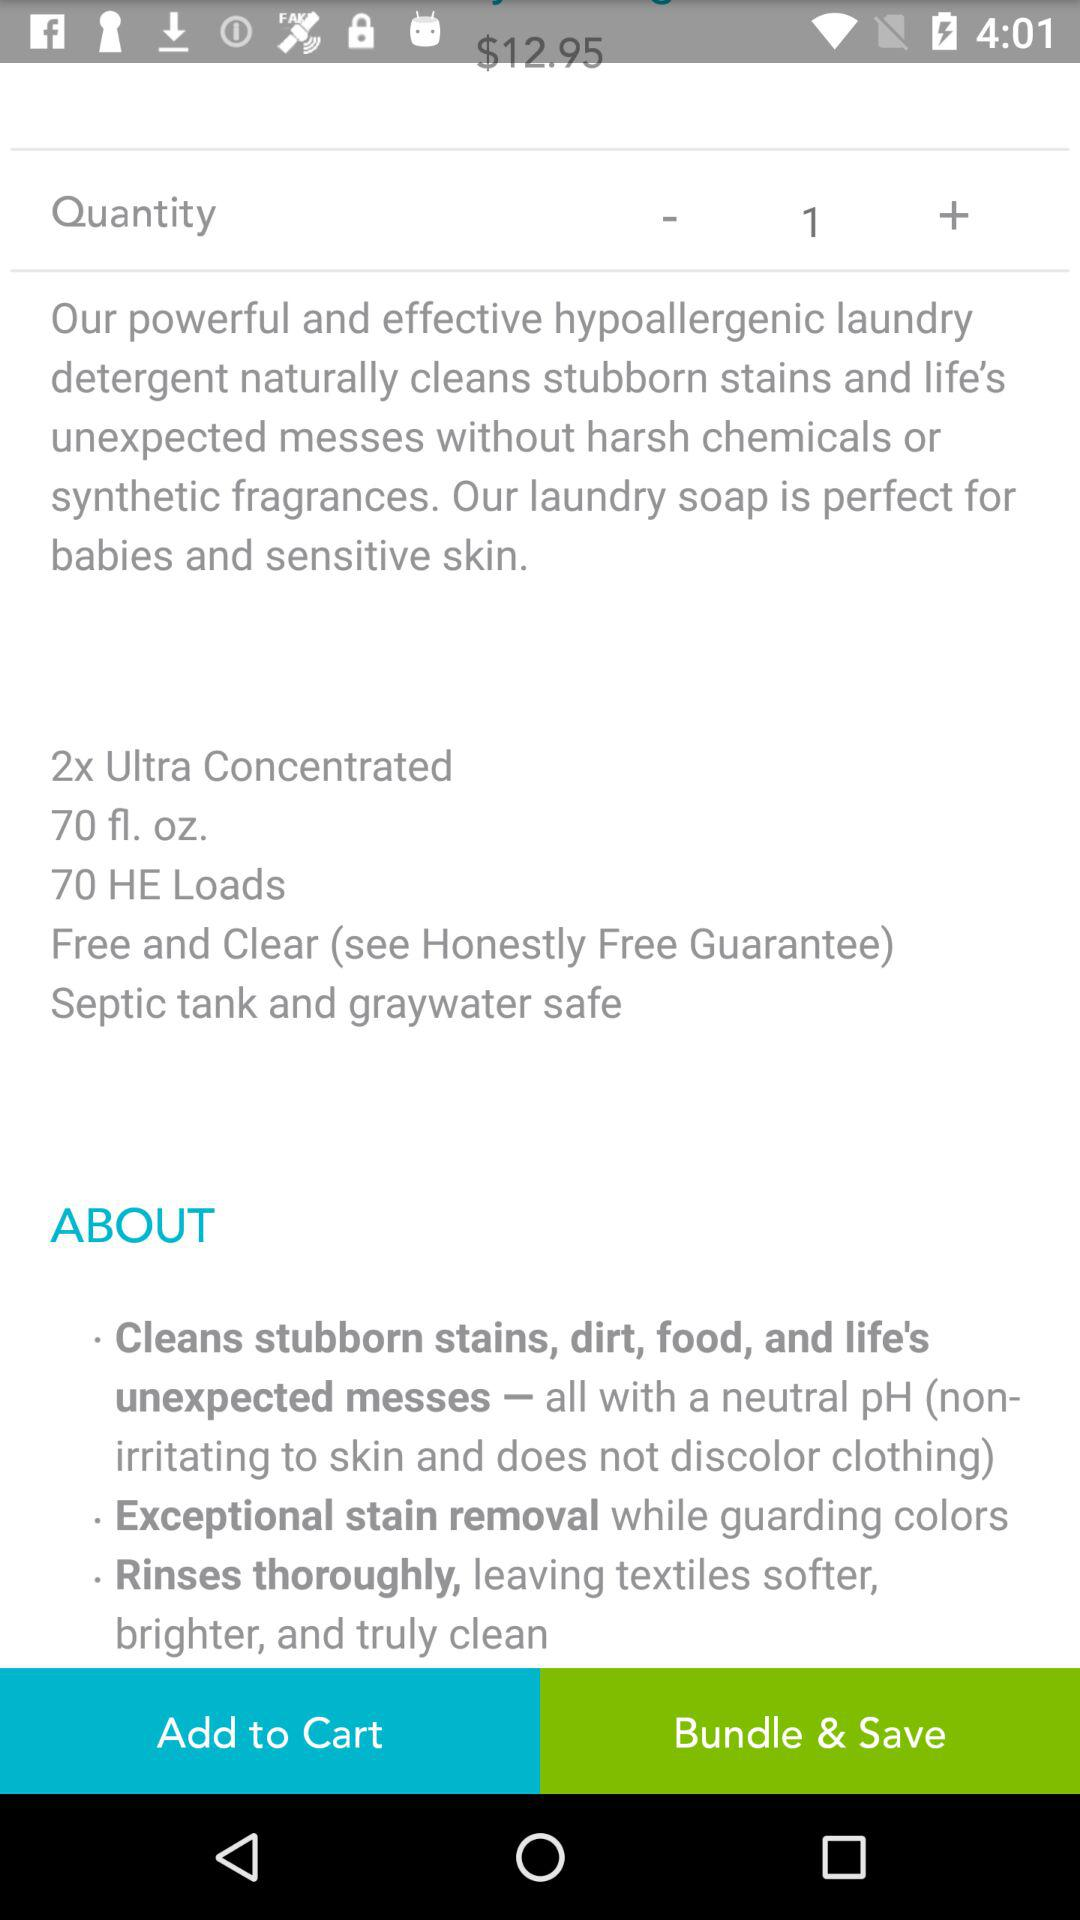What quantity of detergent is added? The added quantity of detergent is 1. 